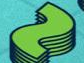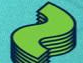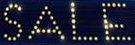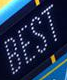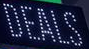What text is displayed in these images sequentially, separated by a semicolon? ~; ~; SALE; BEST; DEALS 